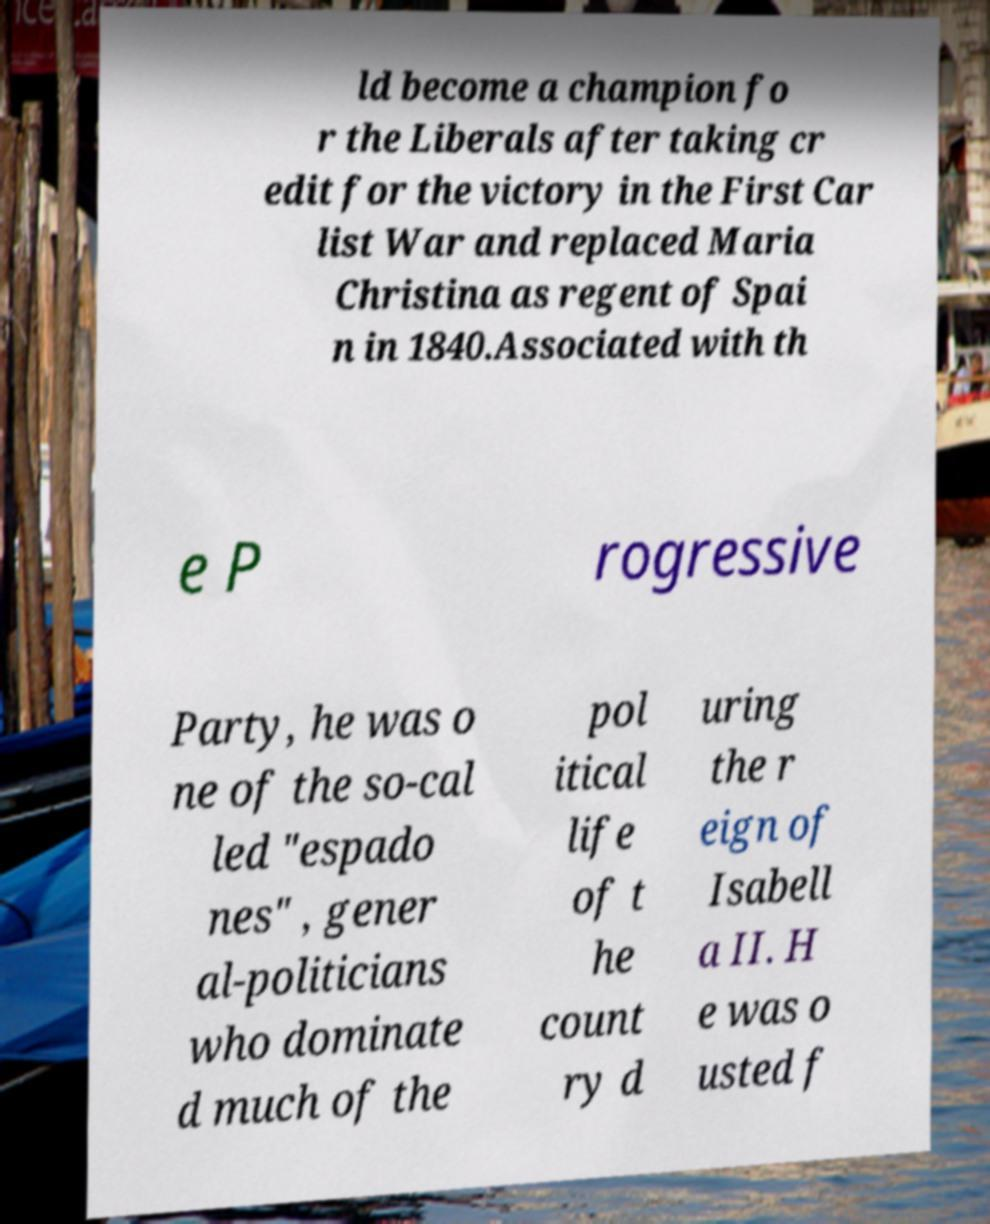For documentation purposes, I need the text within this image transcribed. Could you provide that? ld become a champion fo r the Liberals after taking cr edit for the victory in the First Car list War and replaced Maria Christina as regent of Spai n in 1840.Associated with th e P rogressive Party, he was o ne of the so-cal led "espado nes" , gener al-politicians who dominate d much of the pol itical life of t he count ry d uring the r eign of Isabell a II. H e was o usted f 